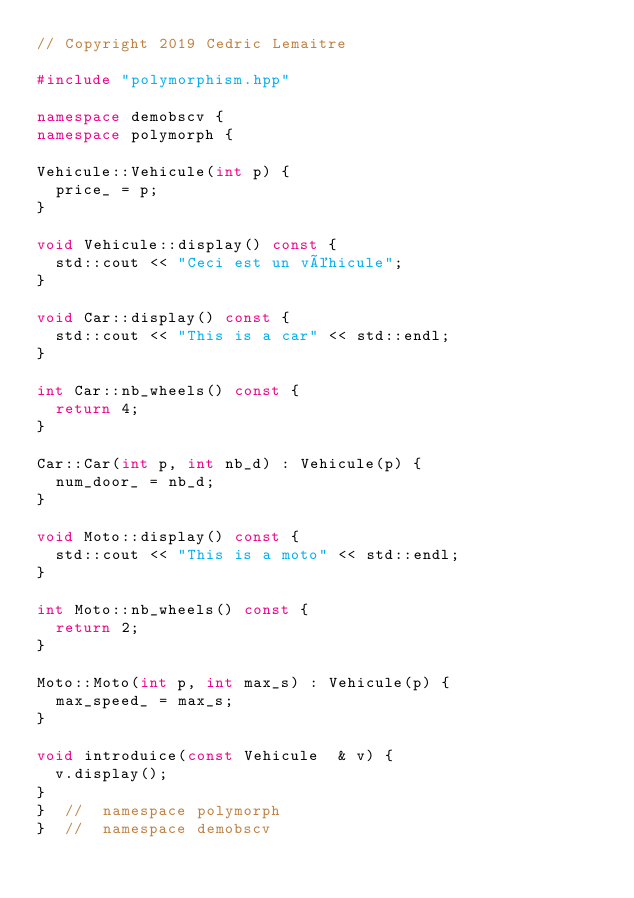<code> <loc_0><loc_0><loc_500><loc_500><_C++_>// Copyright 2019 Cedric Lemaitre

#include "polymorphism.hpp"

namespace demobscv {
namespace polymorph {

Vehicule::Vehicule(int p) {
  price_ = p;
}

void Vehicule::display() const {
  std::cout << "Ceci est un véhicule";
}

void Car::display() const {
  std::cout << "This is a car" << std::endl;
}

int Car::nb_wheels() const {
  return 4;
}

Car::Car(int p, int nb_d) : Vehicule(p) {
  num_door_ = nb_d;
}

void Moto::display() const {
  std::cout << "This is a moto" << std::endl;
}

int Moto::nb_wheels() const {
  return 2;
}

Moto::Moto(int p, int max_s) : Vehicule(p) {
  max_speed_ = max_s;
}

void introduice(const Vehicule  & v) {
  v.display();
}
}  //  namespace polymorph
}  //  namespace demobscv
</code> 